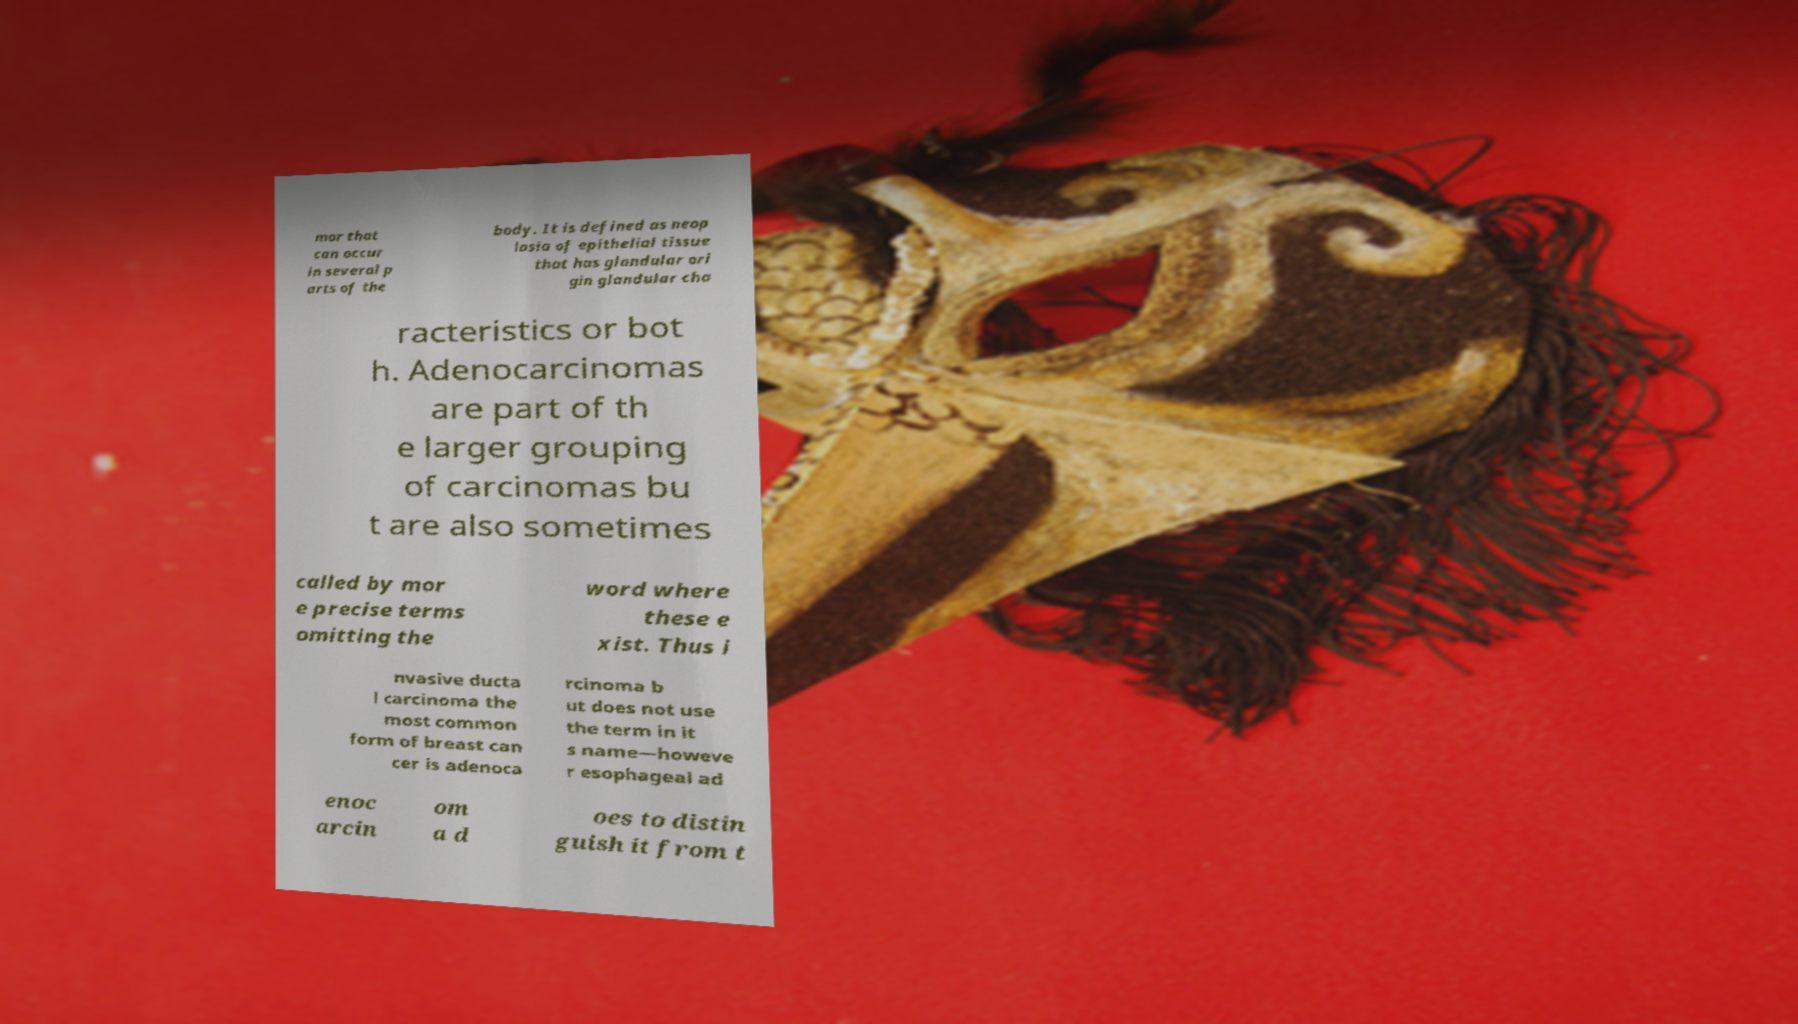What messages or text are displayed in this image? I need them in a readable, typed format. mor that can occur in several p arts of the body. It is defined as neop lasia of epithelial tissue that has glandular ori gin glandular cha racteristics or bot h. Adenocarcinomas are part of th e larger grouping of carcinomas bu t are also sometimes called by mor e precise terms omitting the word where these e xist. Thus i nvasive ducta l carcinoma the most common form of breast can cer is adenoca rcinoma b ut does not use the term in it s name—howeve r esophageal ad enoc arcin om a d oes to distin guish it from t 